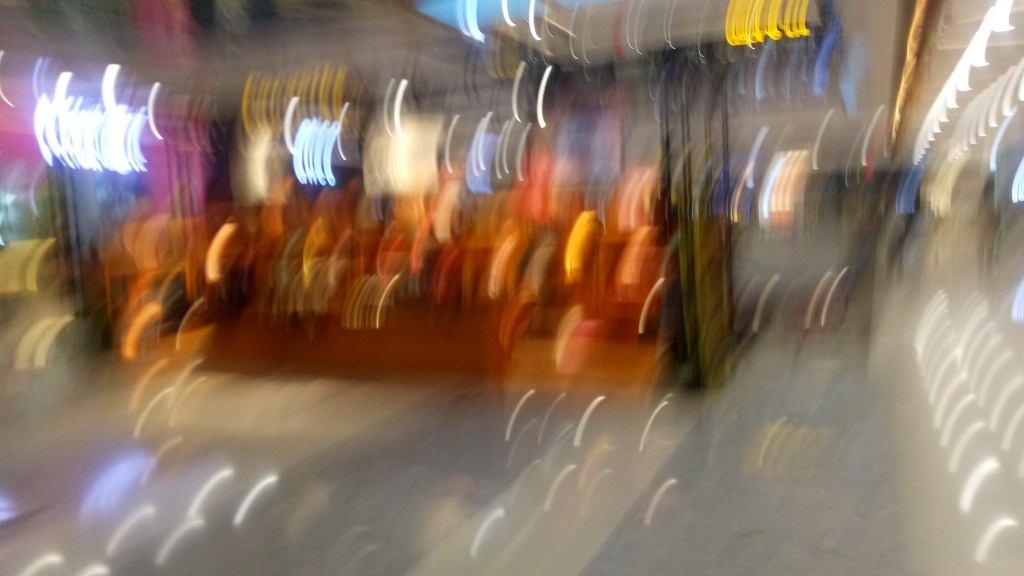Can you suggest what this place might be despite the blur? Despite the blur, the bright lighting and what appears to be rows of hangers or racks suggest this could be an indoor setting, possibly a retail store or a similar commercial space. Is there anything in this image that indicates it could have been taken during a specific time of day or event? The image quality is quite poor, but the artificial lighting and lack of natural light coming through could imply the photo was taken in the evening or at night, or simply inside a space without windows. There's no clear indication of a specific event occurring at the time the photo was taken. 